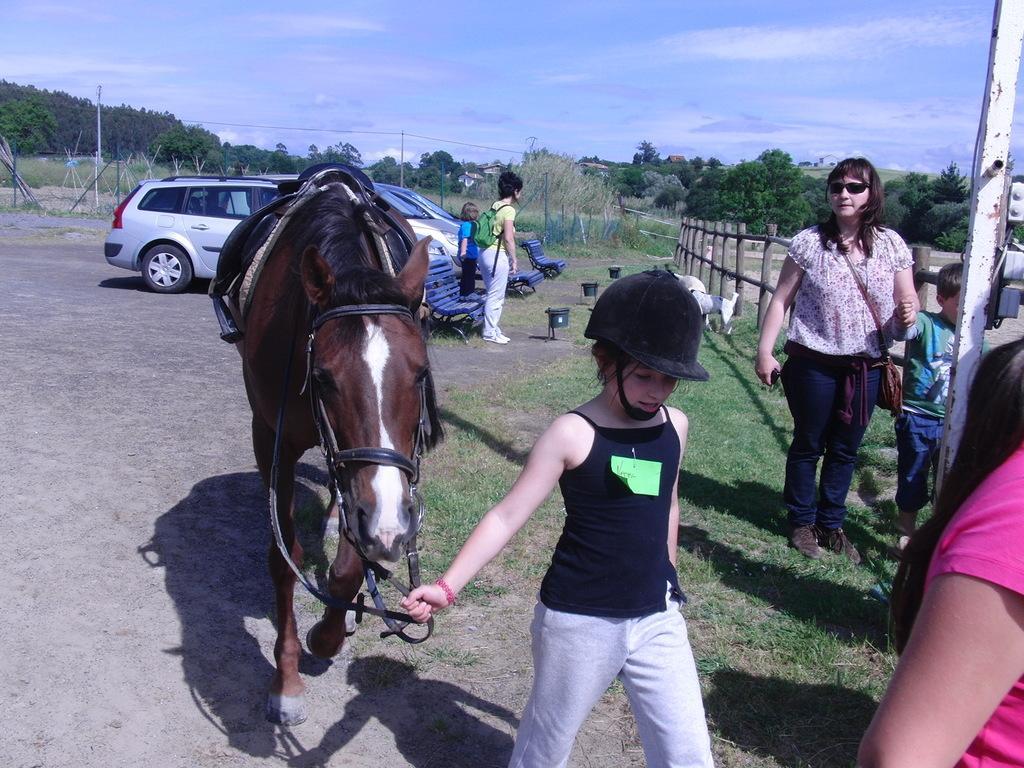Can you describe this image briefly? In this image, we can see people wearing clothes. There are some trees, cars, benches and lights in the middle of the image. There is a horse at the bottom of the image. There is a pole and fence on the right side of the image. There are clouds in the sky. 